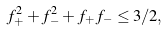<formula> <loc_0><loc_0><loc_500><loc_500>f _ { + } ^ { 2 } + f _ { - } ^ { 2 } + f _ { + } f _ { - } \leq 3 / 2 ,</formula> 